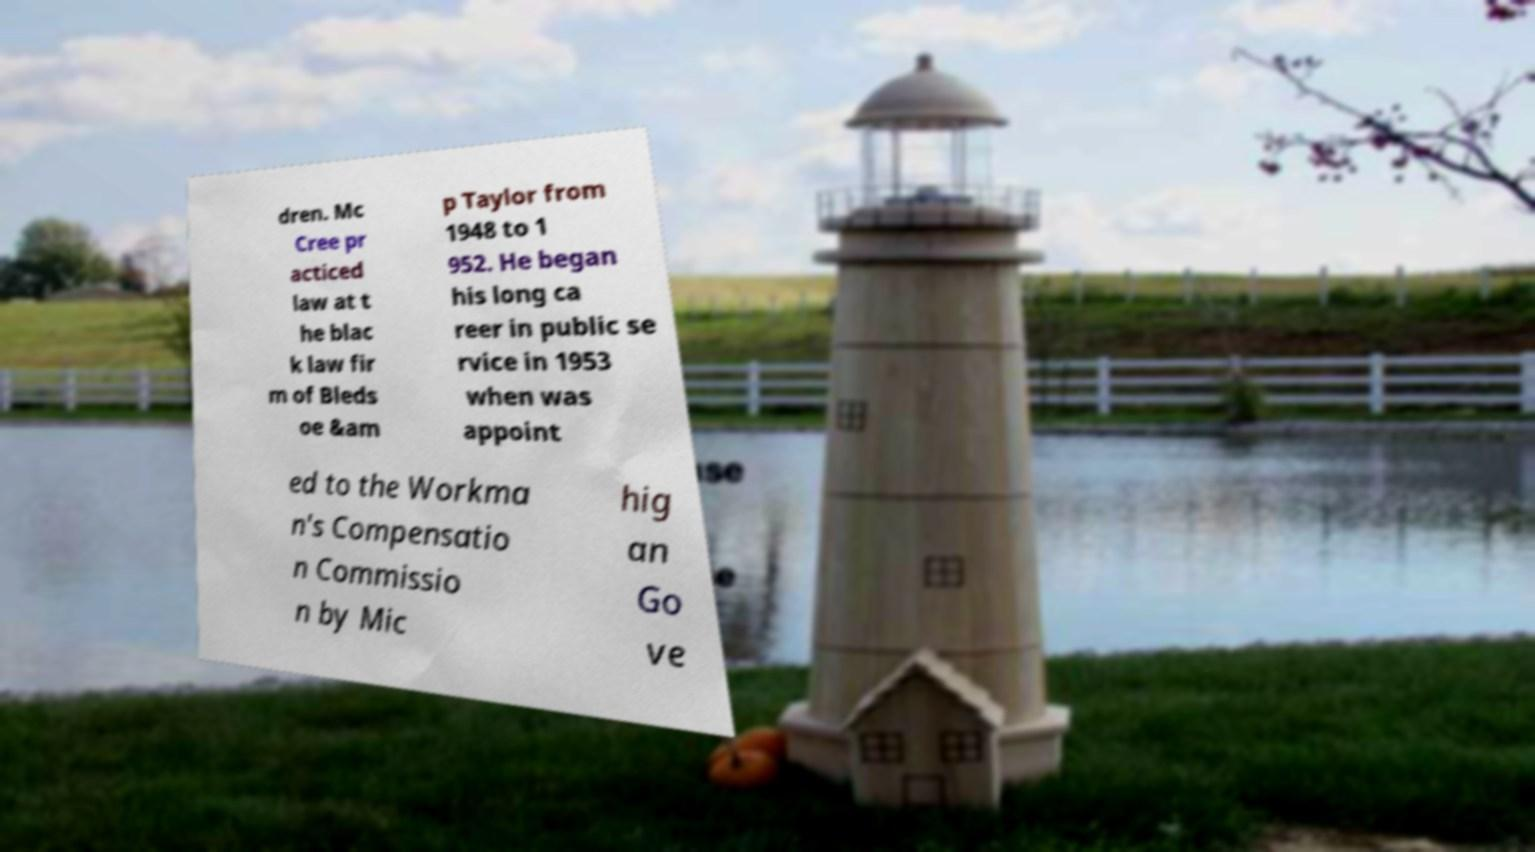Can you read and provide the text displayed in the image?This photo seems to have some interesting text. Can you extract and type it out for me? dren. Mc Cree pr acticed law at t he blac k law fir m of Bleds oe &am p Taylor from 1948 to 1 952. He began his long ca reer in public se rvice in 1953 when was appoint ed to the Workma n's Compensatio n Commissio n by Mic hig an Go ve 